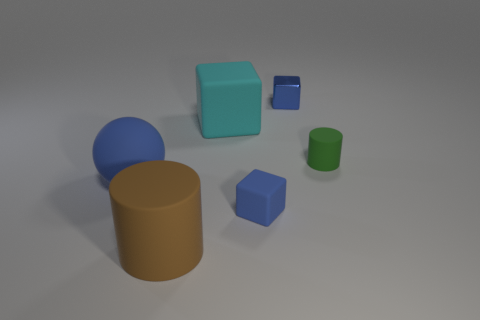Is the material of the green object the same as the big cyan object?
Keep it short and to the point. Yes. What size is the cylinder to the left of the blue block that is left of the small blue block that is behind the big blue rubber thing?
Make the answer very short. Large. What number of other objects are the same color as the small cylinder?
Keep it short and to the point. 0. There is a green object that is the same size as the blue shiny cube; what shape is it?
Offer a terse response. Cylinder. How many tiny objects are either green matte objects or matte things?
Offer a very short reply. 2. There is a small cube that is in front of the matte cube that is behind the large sphere; is there a large brown thing that is behind it?
Ensure brevity in your answer.  No. Are there any red cylinders of the same size as the brown rubber object?
Make the answer very short. No. There is a cylinder that is the same size as the cyan rubber thing; what is it made of?
Offer a very short reply. Rubber. Does the rubber sphere have the same size as the rubber block behind the green thing?
Keep it short and to the point. Yes. What number of metallic objects are either tiny purple cylinders or small green cylinders?
Provide a short and direct response. 0. 